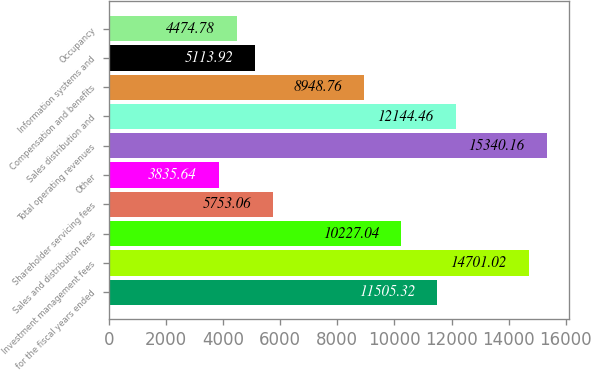<chart> <loc_0><loc_0><loc_500><loc_500><bar_chart><fcel>for the fiscal years ended<fcel>Investment management fees<fcel>Sales and distribution fees<fcel>Shareholder servicing fees<fcel>Other<fcel>Total operating revenues<fcel>Sales distribution and<fcel>Compensation and benefits<fcel>Information systems and<fcel>Occupancy<nl><fcel>11505.3<fcel>14701<fcel>10227<fcel>5753.06<fcel>3835.64<fcel>15340.2<fcel>12144.5<fcel>8948.76<fcel>5113.92<fcel>4474.78<nl></chart> 